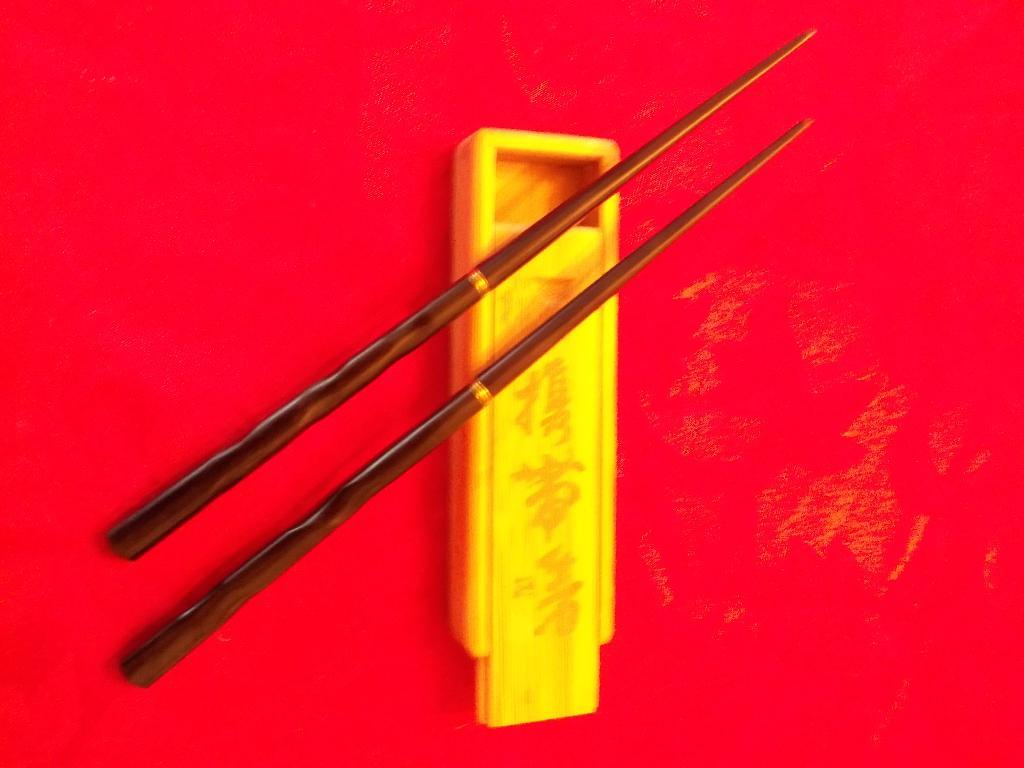What utensils are present in the image? There are two chopsticks in the image. What are the chopsticks placed on? The chopsticks are on an object. What type of lock is used to secure the chopsticks in the image? There is no lock present in the image; the chopsticks are simply placed on an object. 